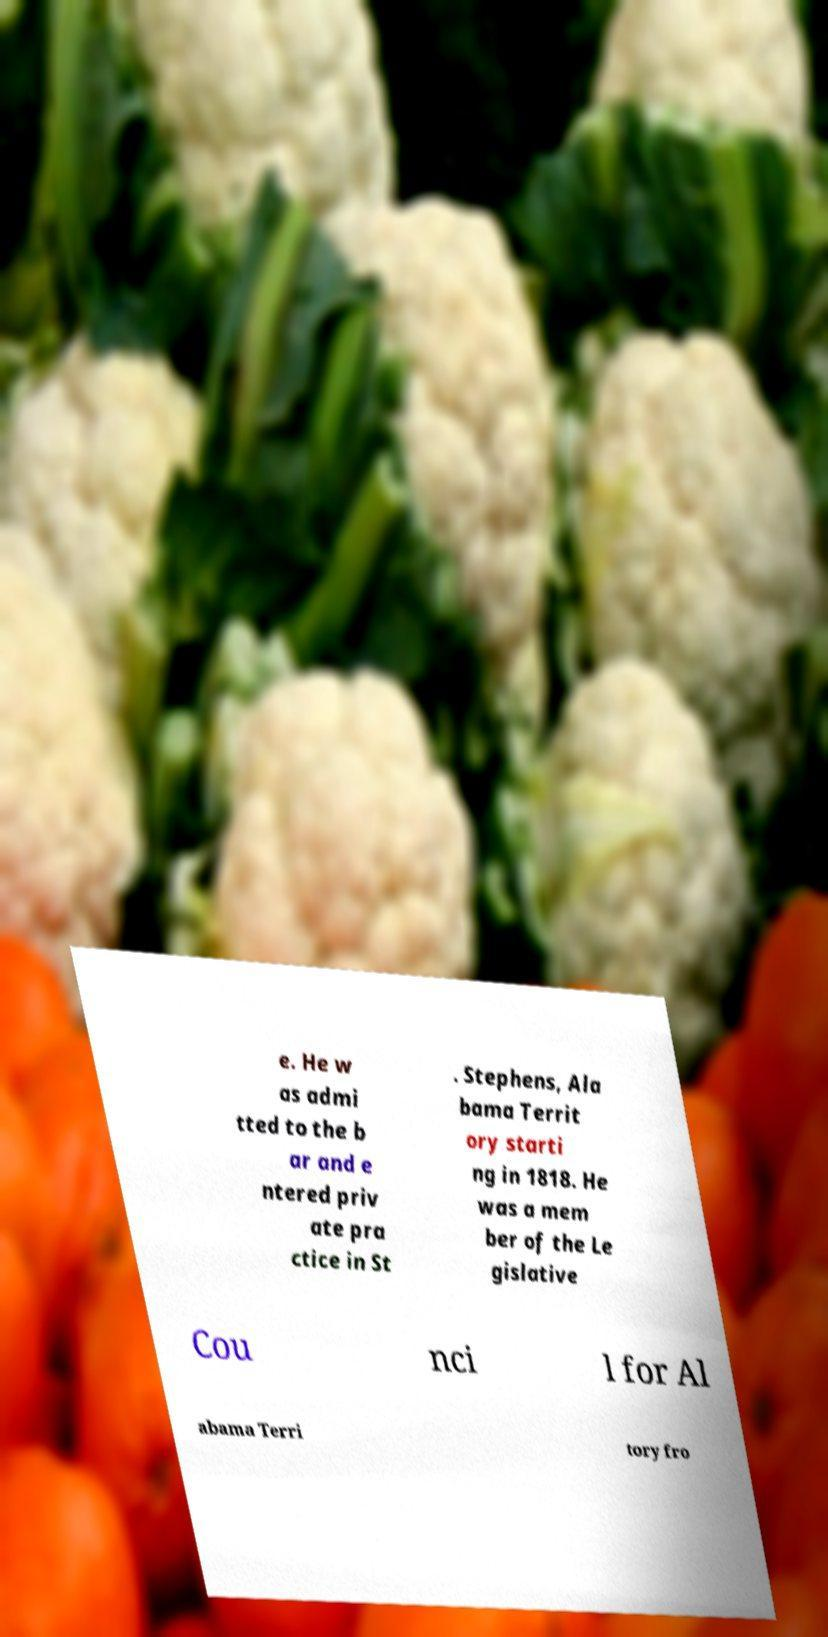For documentation purposes, I need the text within this image transcribed. Could you provide that? e. He w as admi tted to the b ar and e ntered priv ate pra ctice in St . Stephens, Ala bama Territ ory starti ng in 1818. He was a mem ber of the Le gislative Cou nci l for Al abama Terri tory fro 